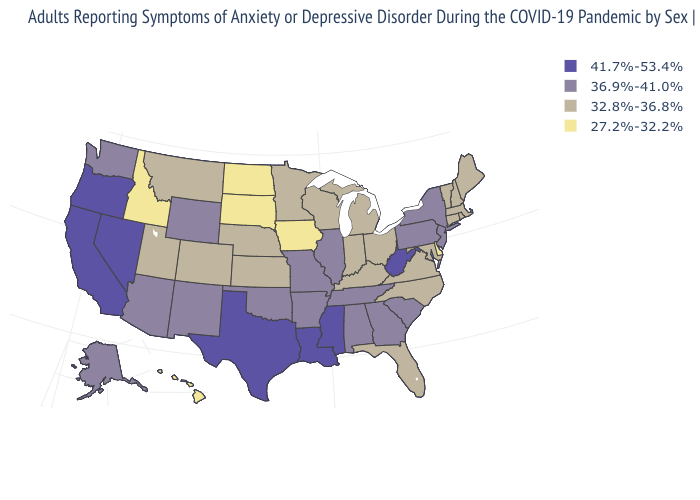What is the lowest value in the West?
Keep it brief. 27.2%-32.2%. Among the states that border Oregon , does California have the highest value?
Write a very short answer. Yes. Does South Carolina have the same value as Maryland?
Write a very short answer. No. Name the states that have a value in the range 41.7%-53.4%?
Keep it brief. California, Louisiana, Mississippi, Nevada, Oregon, Texas, West Virginia. Does Kansas have a higher value than Illinois?
Answer briefly. No. What is the value of Louisiana?
Concise answer only. 41.7%-53.4%. Does Oklahoma have a lower value than Florida?
Write a very short answer. No. What is the highest value in the Northeast ?
Short answer required. 36.9%-41.0%. Name the states that have a value in the range 36.9%-41.0%?
Keep it brief. Alabama, Alaska, Arizona, Arkansas, Georgia, Illinois, Missouri, New Jersey, New Mexico, New York, Oklahoma, Pennsylvania, South Carolina, Tennessee, Washington, Wyoming. Does North Dakota have the lowest value in the MidWest?
Concise answer only. Yes. What is the value of Maine?
Be succinct. 32.8%-36.8%. Does the map have missing data?
Keep it brief. No. Name the states that have a value in the range 36.9%-41.0%?
Short answer required. Alabama, Alaska, Arizona, Arkansas, Georgia, Illinois, Missouri, New Jersey, New Mexico, New York, Oklahoma, Pennsylvania, South Carolina, Tennessee, Washington, Wyoming. Among the states that border Mississippi , does Louisiana have the highest value?
Be succinct. Yes. 